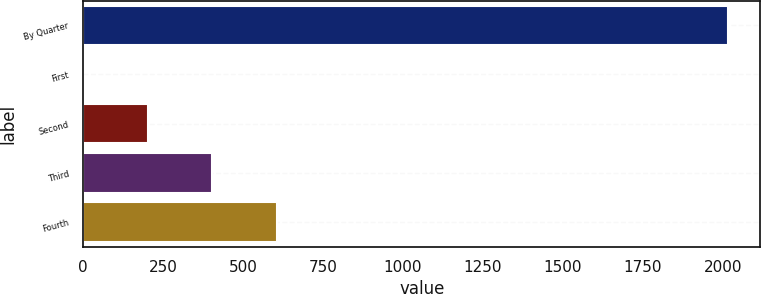<chart> <loc_0><loc_0><loc_500><loc_500><bar_chart><fcel>By Quarter<fcel>First<fcel>Second<fcel>Third<fcel>Fourth<nl><fcel>2016<fcel>0.66<fcel>202.19<fcel>403.72<fcel>605.25<nl></chart> 